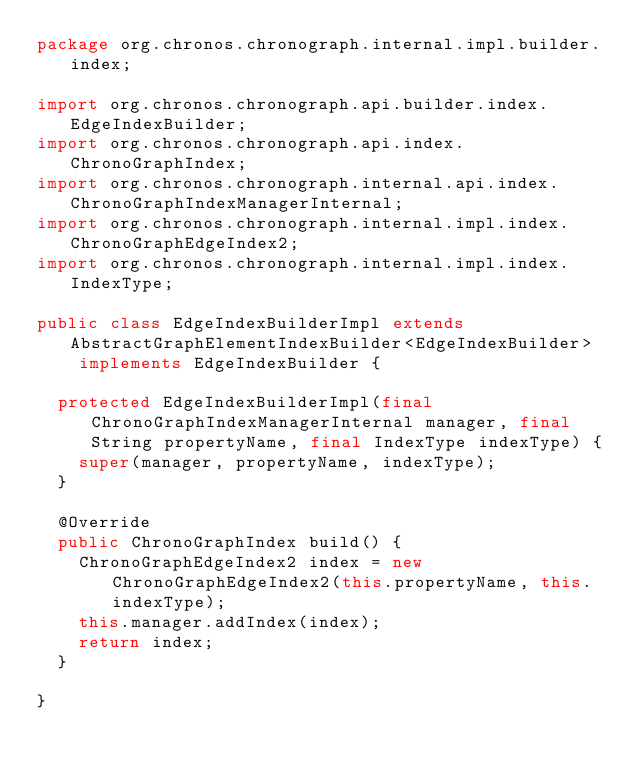Convert code to text. <code><loc_0><loc_0><loc_500><loc_500><_Java_>package org.chronos.chronograph.internal.impl.builder.index;

import org.chronos.chronograph.api.builder.index.EdgeIndexBuilder;
import org.chronos.chronograph.api.index.ChronoGraphIndex;
import org.chronos.chronograph.internal.api.index.ChronoGraphIndexManagerInternal;
import org.chronos.chronograph.internal.impl.index.ChronoGraphEdgeIndex2;
import org.chronos.chronograph.internal.impl.index.IndexType;

public class EdgeIndexBuilderImpl extends AbstractGraphElementIndexBuilder<EdgeIndexBuilder>
		implements EdgeIndexBuilder {

	protected EdgeIndexBuilderImpl(final ChronoGraphIndexManagerInternal manager, final String propertyName, final IndexType indexType) {
		super(manager, propertyName, indexType);
	}

	@Override
	public ChronoGraphIndex build() {
		ChronoGraphEdgeIndex2 index = new ChronoGraphEdgeIndex2(this.propertyName, this.indexType);
		this.manager.addIndex(index);
		return index;
	}

}
</code> 